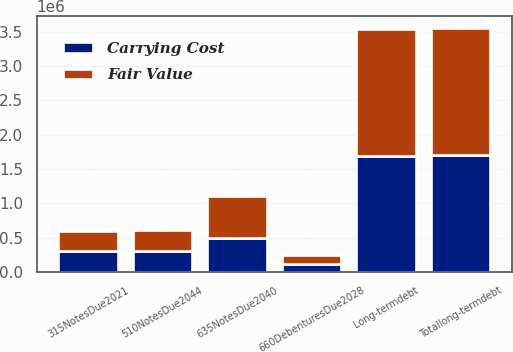Convert chart. <chart><loc_0><loc_0><loc_500><loc_500><stacked_bar_chart><ecel><fcel>635NotesDue2040<fcel>510NotesDue2044<fcel>315NotesDue2021<fcel>660DebenturesDue2028<fcel>Totallong-termdebt<fcel>Long-termdebt<nl><fcel>Carrying Cost<fcel>500000<fcel>300000<fcel>300000<fcel>109895<fcel>1.7099e+06<fcel>1.69361e+06<nl><fcel>Fair Value<fcel>601800<fcel>313320<fcel>302640<fcel>131390<fcel>1.83745e+06<fcel>1.83745e+06<nl></chart> 